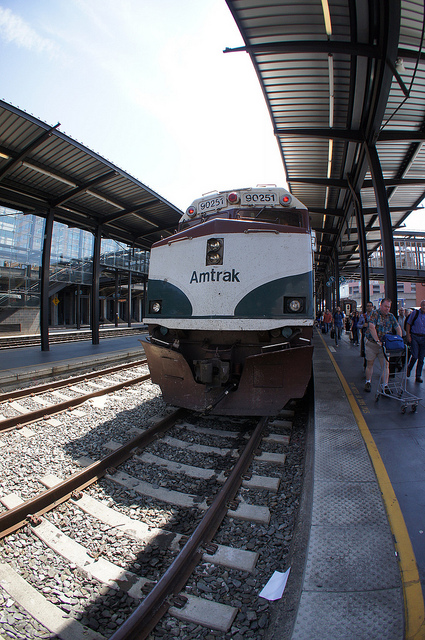Identify the text displayed in this image. Amtrak 90251 90251 